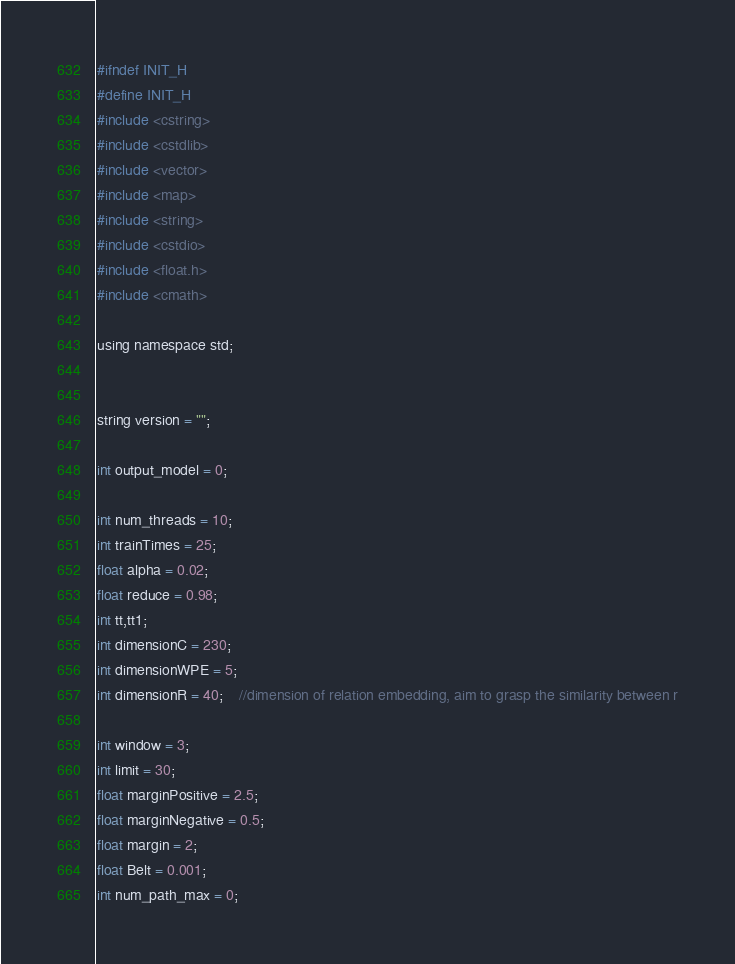<code> <loc_0><loc_0><loc_500><loc_500><_C_>#ifndef INIT_H
#define INIT_H
#include <cstring>
#include <cstdlib>
#include <vector>
#include <map>
#include <string>
#include <cstdio>
#include <float.h>
#include <cmath>

using namespace std;


string version = "";

int output_model = 0;

int num_threads = 10;
int trainTimes = 25;
float alpha = 0.02;
float reduce = 0.98;
int tt,tt1;
int dimensionC = 230;
int dimensionWPE = 5;
int dimensionR = 40;	//dimension of relation embedding, aim to grasp the similarity between r

int window = 3;
int limit = 30;
float marginPositive = 2.5;
float marginNegative = 0.5;
float margin = 2;
float Belt = 0.001;
int num_path_max = 0;</code> 